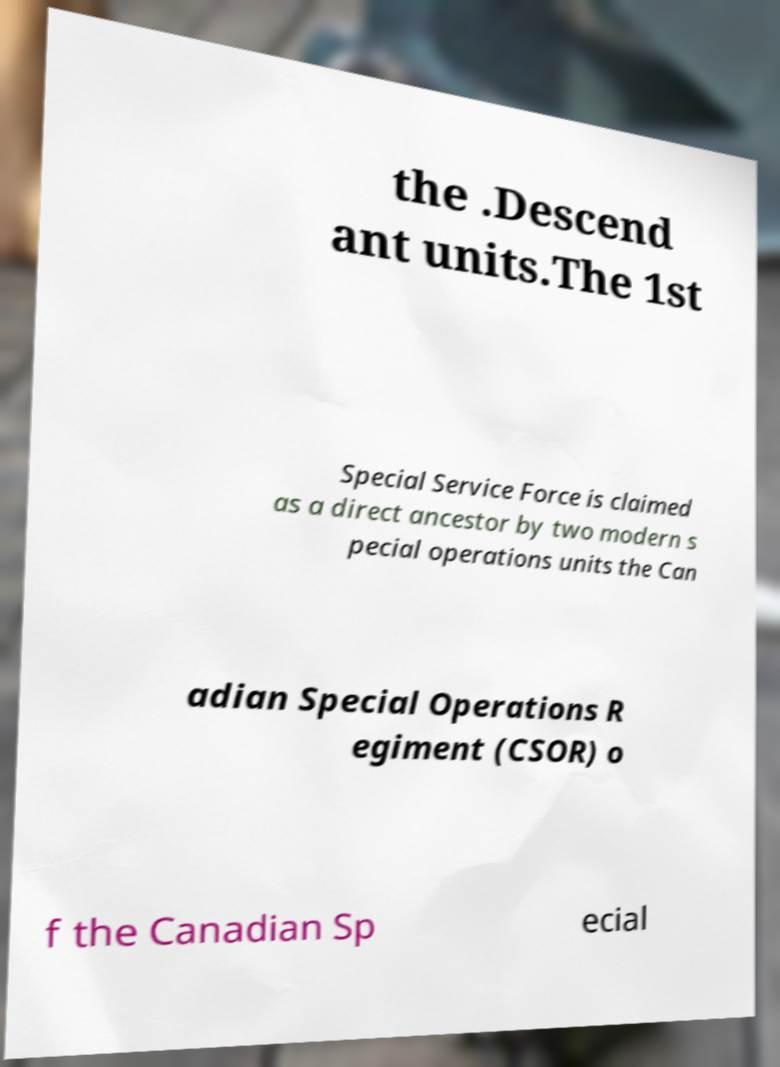Please identify and transcribe the text found in this image. the .Descend ant units.The 1st Special Service Force is claimed as a direct ancestor by two modern s pecial operations units the Can adian Special Operations R egiment (CSOR) o f the Canadian Sp ecial 